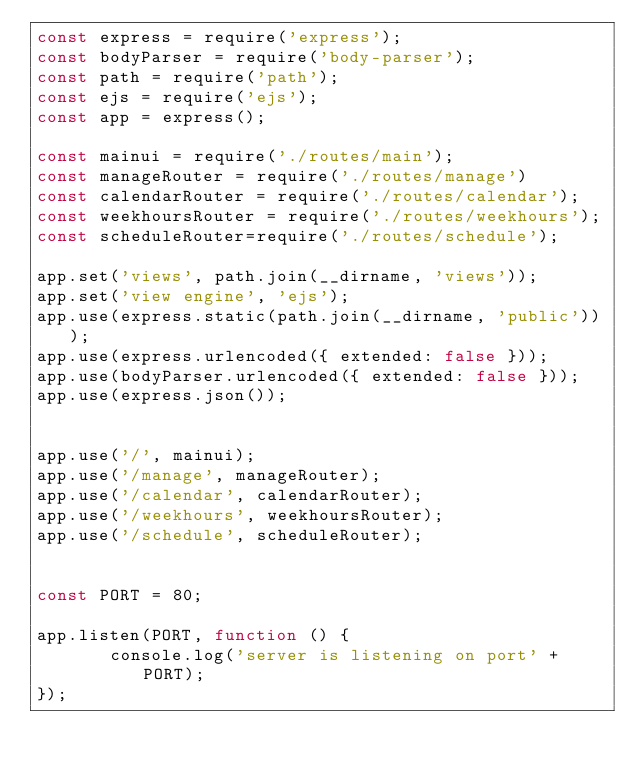Convert code to text. <code><loc_0><loc_0><loc_500><loc_500><_JavaScript_>const express = require('express');
const bodyParser = require('body-parser');
const path = require('path');
const ejs = require('ejs');
const app = express();

const mainui = require('./routes/main');
const manageRouter = require('./routes/manage')
const calendarRouter = require('./routes/calendar');
const weekhoursRouter = require('./routes/weekhours');
const scheduleRouter=require('./routes/schedule');

app.set('views', path.join(__dirname, 'views'));  
app.set('view engine', 'ejs');                    
app.use(express.static(path.join(__dirname, 'public')));   
app.use(express.urlencoded({ extended: false }));
app.use(bodyParser.urlencoded({ extended: false }));
app.use(express.json());


app.use('/', mainui);
app.use('/manage', manageRouter);
app.use('/calendar', calendarRouter);
app.use('/weekhours', weekhoursRouter);
app.use('/schedule', scheduleRouter);


const PORT = 80;

app.listen(PORT, function () {
       console.log('server is listening on port' + PORT);
});
</code> 